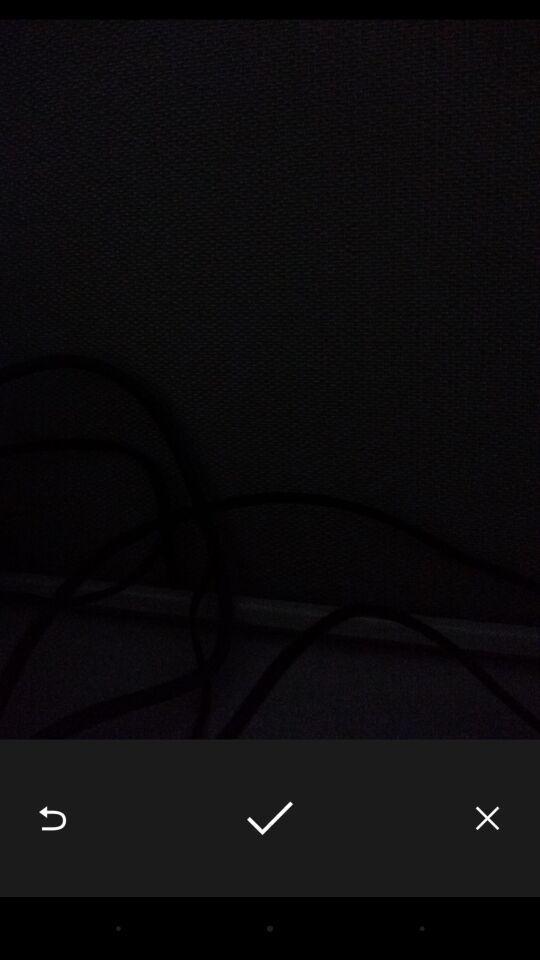Describe the key features of this screenshot. Page to accept an image in a multimedia app. 